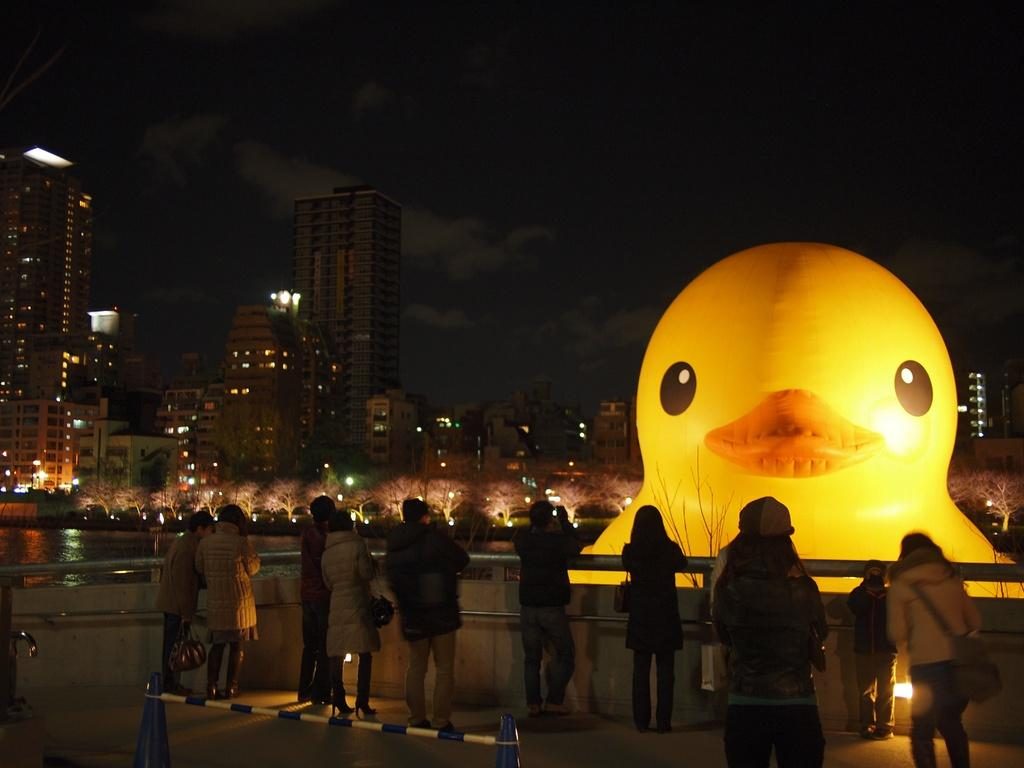What are the people in the image doing? The people in the image are standing and watching a balloon. What is located in front of the people? There is a lake in front of the people. What can be seen on the other side of the lake? There are buildings on the other side of the lake. Where are the kittens playing in the image? There are no kittens present in the image. What type of berry can be seen growing near the lake? There is no berry visible in the image; it only shows people watching a balloon, a lake, and buildings on the other side. 